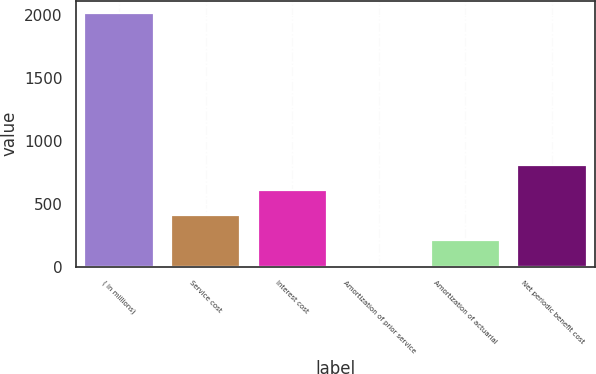<chart> <loc_0><loc_0><loc_500><loc_500><bar_chart><fcel>( in millions)<fcel>Service cost<fcel>Interest cost<fcel>Amortization of prior service<fcel>Amortization of actuarial<fcel>Net periodic benefit cost<nl><fcel>2014<fcel>410.8<fcel>611.2<fcel>10<fcel>210.4<fcel>811.6<nl></chart> 